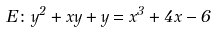<formula> <loc_0><loc_0><loc_500><loc_500>E \colon y ^ { 2 } + x y + y = x ^ { 3 } + 4 x - 6</formula> 